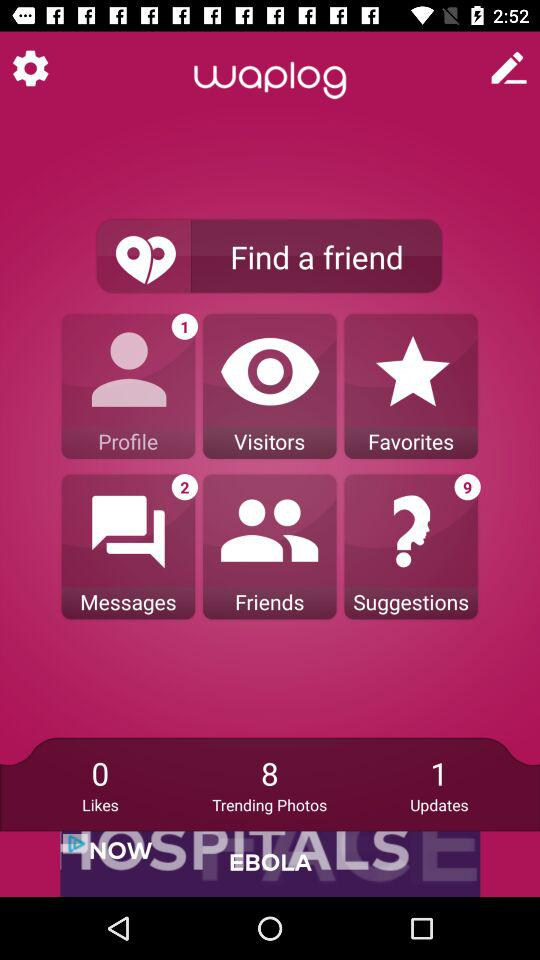How many suggestions are pending? There are 9 pending suggestions. 